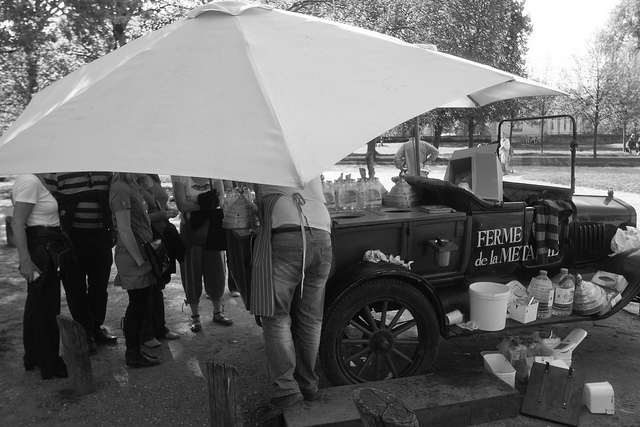<image>Are they serving drinks? I am not sure if they are serving drinks. Are they serving drinks? I don't know if they are serving drinks. It can be both yes or no. 